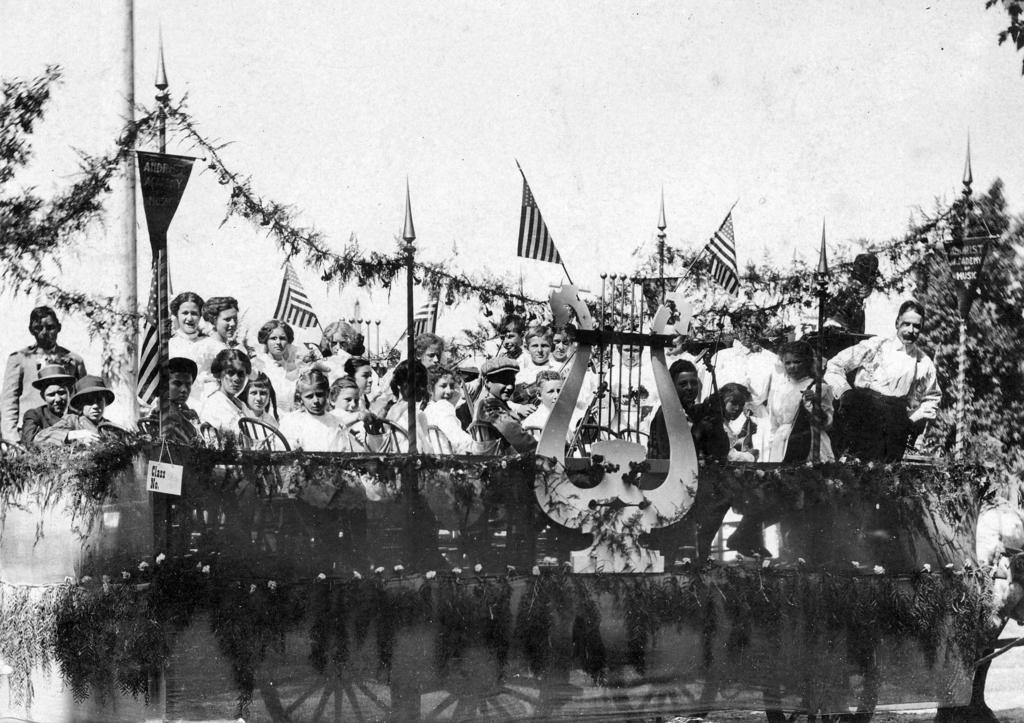What is the color scheme of the image? The image is black and white. What can be seen in the image? There is a group of people and flags in the image. What other elements are present in the image? There are trees in the image. What can be seen in the background of the image? The sky is visible in the background of the image. What type of glove is being worn by the grandfather in the image? There is no grandfather or glove present in the image. What is the belief system of the people in the image? The image does not provide any information about the belief system of the people. 